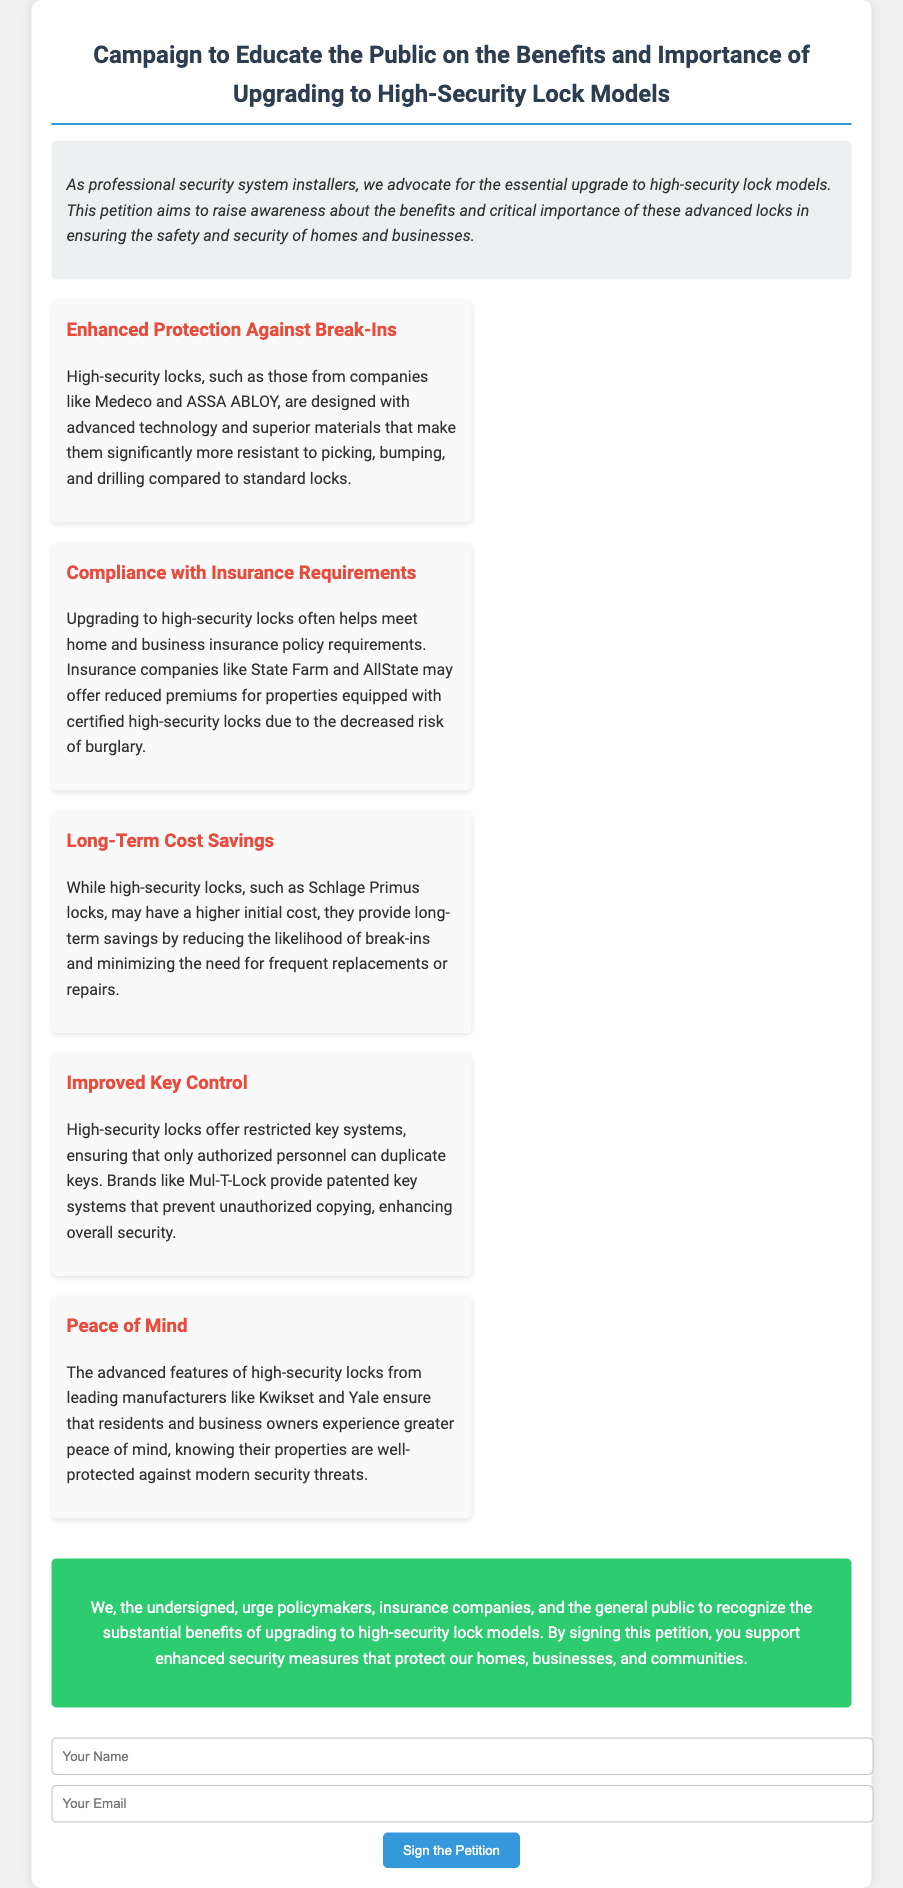What is the title of the petition? The title is found in the header of the document which states the primary focus of the petition.
Answer: Campaign to Educate the Public on the Benefits and Importance of Upgrading to High-Security Lock Models What type of locks are being promoted in this petition? The document specifies high-security locks that provide enhanced safety and security.
Answer: High-security locks Which companies are mentioned as examples of lock manufacturers? The document lists specific companies to emphasize the credibility and quality of high-security locks.
Answer: Medeco, ASSA ABLOY, Schlage, Mul-T-Lock, Kwikset, Yale What is one benefit of high-security locks according to the petition? The petition highlights various advantages, with an emphasis on enhanced protection and compliance with insurance.
Answer: Enhanced Protection Against Break-Ins How can upgrading to high-security locks affect insurance premiums? This outcome is mentioned as part of the petition to inform people about financial benefits tied to security.
Answer: Reduced premiums What does the petition encourage people to do? The main call to action is directed towards supporting the upgrade to high-security locks.
Answer: Sign the petition What is the visual style of the introduction section? The document describes the stylistic choices made for different sections, particularly for the introduction.
Answer: Italic and background color What are the key points structured as? The key points are organized in separate sections which are designed to draw attention to each advantage.
Answer: Flexibly arranged boxes (or "cards") Which specific feature of high-security locks improves key control? The document explains how certain key systems restrict unauthorized duplication as a significant feature of these locks.
Answer: Restricted key systems 